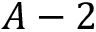<formula> <loc_0><loc_0><loc_500><loc_500>A - 2</formula> 